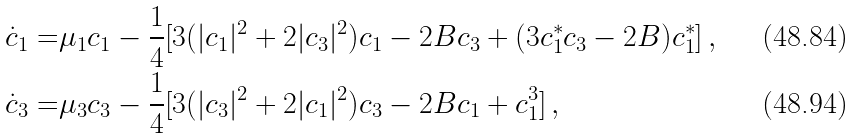Convert formula to latex. <formula><loc_0><loc_0><loc_500><loc_500>\dot { c } _ { 1 } = & \mu _ { 1 } c _ { 1 } - \frac { 1 } { 4 } [ 3 ( | c _ { 1 } | ^ { 2 } + 2 | c _ { 3 } | ^ { 2 } ) c _ { 1 } - 2 B c _ { 3 } + ( 3 c _ { 1 } ^ { * } c _ { 3 } - 2 B ) c _ { 1 } ^ { * } ] \, , \\ \dot { c } _ { 3 } = & \mu _ { 3 } c _ { 3 } - \frac { 1 } { 4 } [ 3 ( | c _ { 3 } | ^ { 2 } + 2 | c _ { 1 } | ^ { 2 } ) c _ { 3 } - 2 B c _ { 1 } + c _ { 1 } ^ { 3 } ] \, ,</formula> 